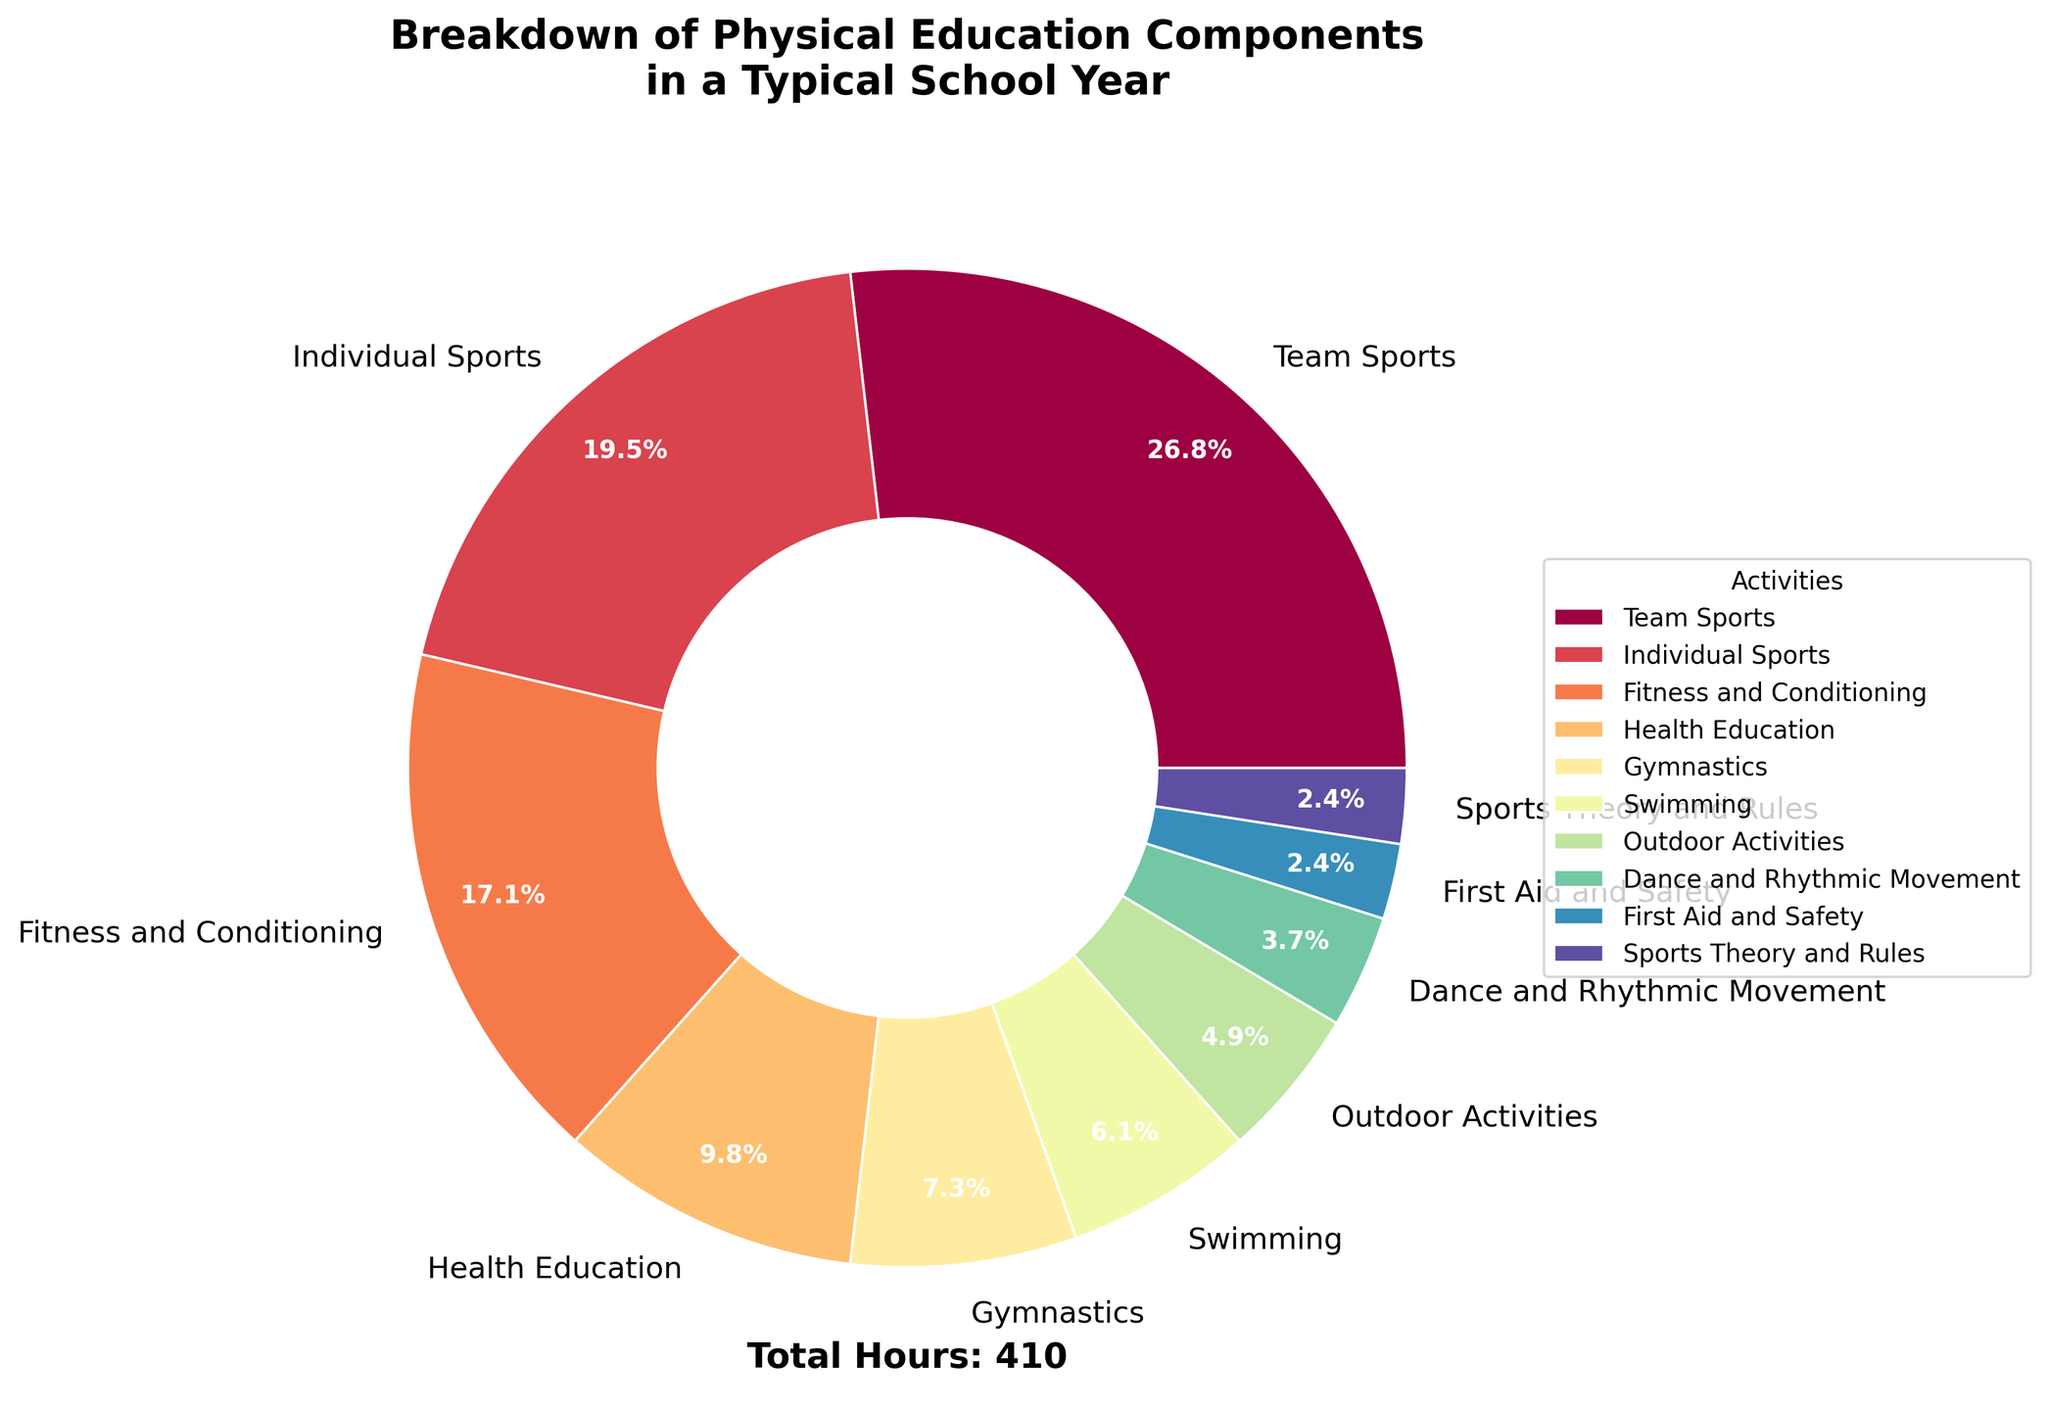What's the most time-consuming activity? The figure shows the hours spent on each activity. By comparing the values, we see that the most time-consuming activity is "Team Sports" with 110 hours.
Answer: Team Sports Which activity has the least amount of hours dedicated to it? The activity with the smallest wedge in the pie chart represents the least time spent. "First Aid and Safety" and "Sports Theory and Rules" each have 10 hours.
Answer: First Aid and Safety and Sports Theory and Rules What is the total percentage of time spent on Health Education and Gymnastics? Each activity's percentage is shown on the pie chart. Health Education is 10.4% and Gymnastics is 7.8%. Summing these, 10.4% + 7.8% = 18.2%.
Answer: 18.2% How many more hours are spent on Team Sports than on Individual Sports? Team Sports has 110 hours, and Individual Sports has 80 hours. The difference between them is 110 - 80 = 30 hours.
Answer: 30 hours Which activity has the closest percentage of time as Swimming? The pie chart shows percentages for each activity. Swimming is at 6.5%. First Aid and Safety are closest with 2.6%, as no other percentages are closer to 6.5%
Answer: First Aid and Safety What is the ratio of hours spent on Team Sports to Individual Sports and Fitness and Conditioning combined? Team Sports has 110 hours. The combined hours for Individual Sports and Fitness and Conditioning is 80 + 70 = 150. The ratio is 110:150, which simplifies to 11:15.
Answer: 11:15 How does the time spent on Dance and Rhythmic Movement compare to Outdoor Activities? Dance and Rhythmic Movement have 15 hours, and Outdoor Activities have 20 hours. So Dance and Rhythmic Movement account for fewer hours.
Answer: Fewer hours What percentage of the total time is dedicated to Gymnastics? The total hours spent are summed up to 410. Gymnastics accounts for 30 hours. The percentage is (30/410) * 100 = 7.3%.
Answer: 7.3% What is the combined percentage for First Aid and Safety and Sports Theory and Rules? First Aid and Safety has 2.4% and Sports Theory and Rules also has 2.4%. The combined percentage is 4.8%.
Answer: 4.8% 